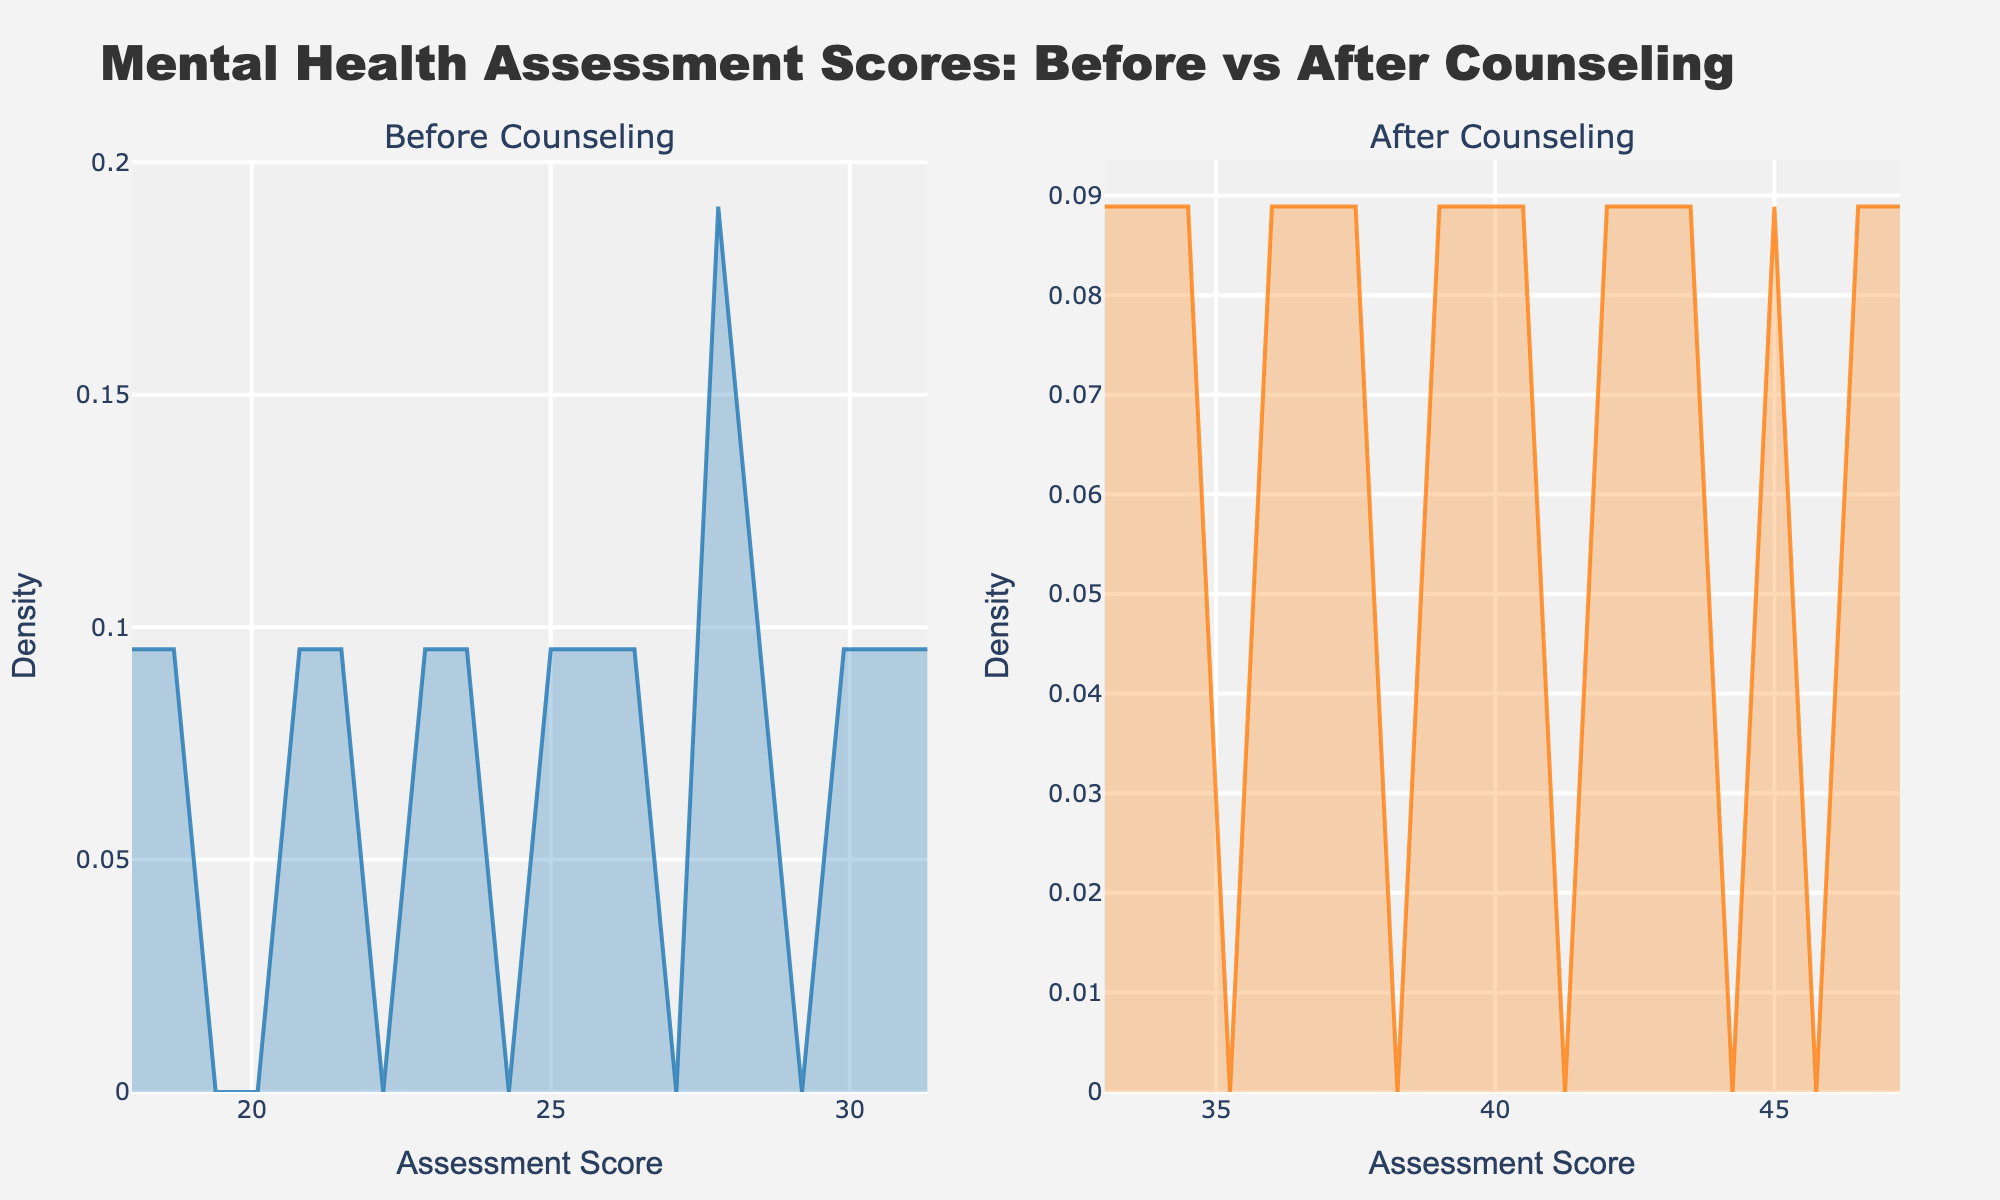What is the title of the figure? The title of a figure is usually displayed prominently at the top and provides a summary of what the figure represents. Looking at the top of the figure, it states "Mental Health Assessment Scores: Before vs After Counseling".
Answer: Mental Health Assessment Scores: Before vs After Counseling What are the labels of the x-axes in the subplots? The labels of the axes are usually placed along the respective axes. For the x-axes in both subplots, the label reads "Assessment Score".
Answer: Assessment Score What are the labels of the y-axes in the subplots? The labels of the axes are usually placed along the respective axes. For the y-axes in both subplots, the label reads "Density".
Answer: Density Which subplot represents the scores before counseling? The titles of each subplot indicate what they represent; the first subplot is titled "Before Counseling", indicating that it represents the scores before counseling.
Answer: The first subplot Which subplot represents the scores after counseling? The titles of each subplot indicate what they represent; the second subplot is titled "After Counseling", indicating that it represents the scores after counseling.
Answer: The second subplot What seems to be the general trend in the density distribution from "before counseling" to "after counseling"? To identify the general trend, observe the shapes and peaks of the density curves in both subplots. Generally, the scores appear more concentrated in higher ranges after counseling compared to before.
Answer: Scores shift to higher ranges How does the distribution's peak change from the "before counseling" subplot to the "after counseling" subplot? To assess changes in the peak, compare the highest points on the density curves. The "before counseling" subplot peaks at a lower assessment score compared to the "after counseling" subplot where the peak shifts higher, indicating improved scores.
Answer: Peak shifts to higher scores In which subplot is the density curve more spread out and why might this be? By comparing the spread of the density curves, observe that the "before counseling" subplot has a broader spread indicating a larger variation in scores, while the "after counseling" subplot is more concentrated. This spread might indicate initial variability in mental health which becomes more uniform post-counseling.
Answer: Before counseling Is there a noticeable difference in the color fill of the density plots, and what might this signify? The color fill helps in distinguishing features. The "before counseling" subplot uses a blue fill, while the "after counseling" subplot uses an orange fill. This difference helps in visual differentiation between the two distributions.
Answer: Yes, blue (before) and orange (after) 